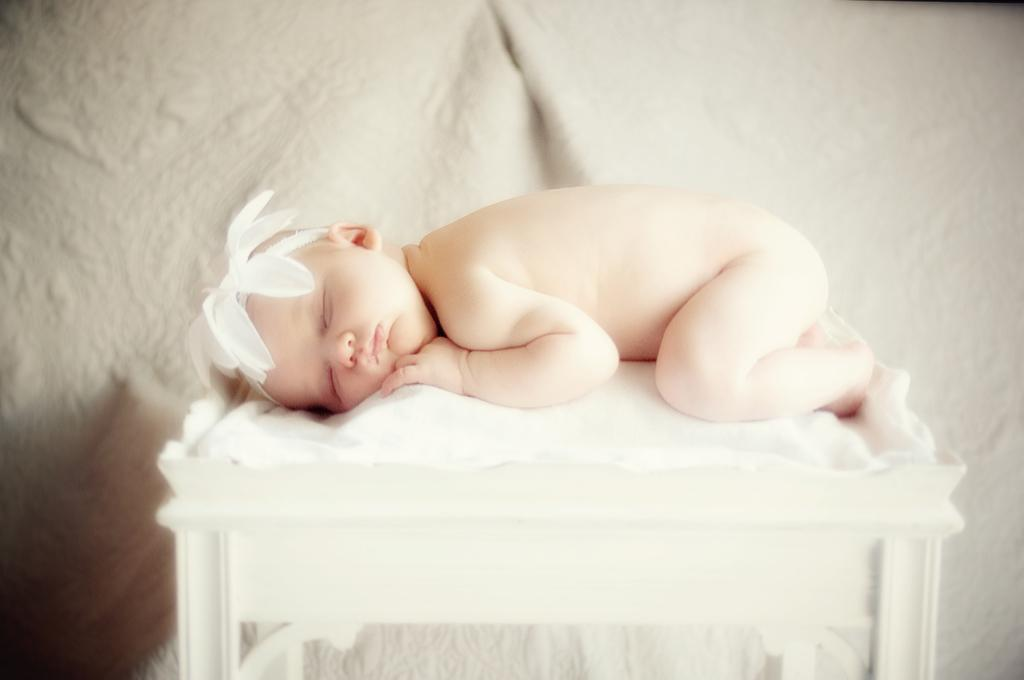What is located at the bottom of the image? There is a table at the bottom of the image. What is covering the table? There is a white cloth on the table. What is happening on the white cloth? A baby is sleeping on the white cloth. What is on the baby's head? The baby has a white color item on its head. Where is the scarecrow located in the image? There is no scarecrow present in the image. Can you tell me how many goldfish are swimming in the sink in the image? There is no sink or goldfish present in the image. 